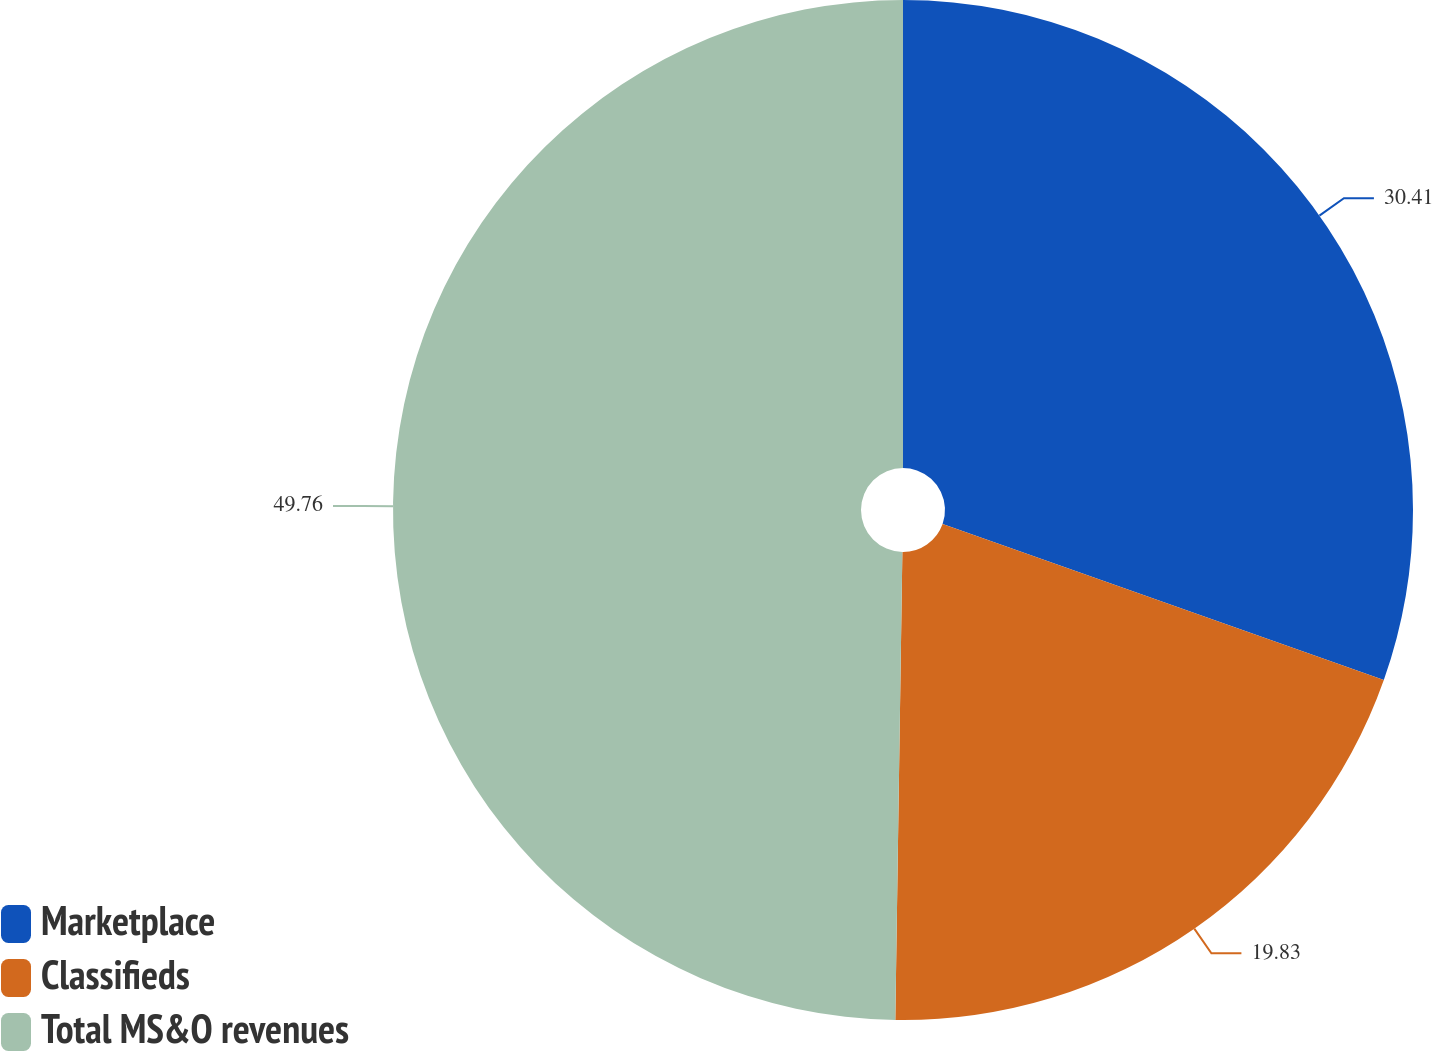<chart> <loc_0><loc_0><loc_500><loc_500><pie_chart><fcel>Marketplace<fcel>Classifieds<fcel>Total MS&O revenues<nl><fcel>30.41%<fcel>19.83%<fcel>49.76%<nl></chart> 